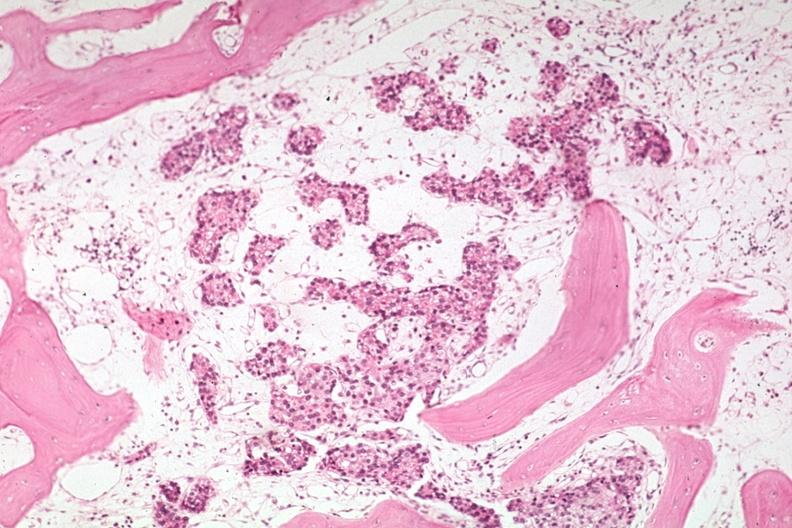what does this image show?
Answer the question using a single word or phrase. Med metastasis in marrow with no evidence of osteoblastic activity 15l893 